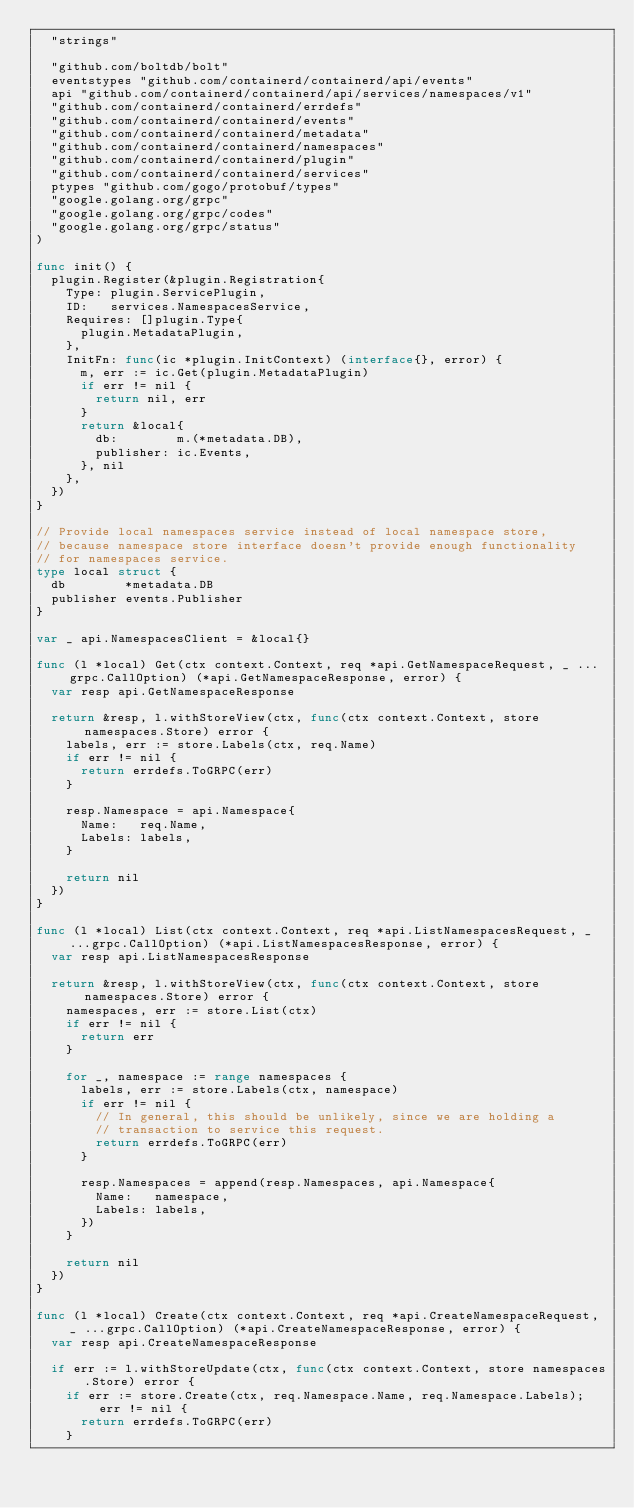<code> <loc_0><loc_0><loc_500><loc_500><_Go_>	"strings"

	"github.com/boltdb/bolt"
	eventstypes "github.com/containerd/containerd/api/events"
	api "github.com/containerd/containerd/api/services/namespaces/v1"
	"github.com/containerd/containerd/errdefs"
	"github.com/containerd/containerd/events"
	"github.com/containerd/containerd/metadata"
	"github.com/containerd/containerd/namespaces"
	"github.com/containerd/containerd/plugin"
	"github.com/containerd/containerd/services"
	ptypes "github.com/gogo/protobuf/types"
	"google.golang.org/grpc"
	"google.golang.org/grpc/codes"
	"google.golang.org/grpc/status"
)

func init() {
	plugin.Register(&plugin.Registration{
		Type: plugin.ServicePlugin,
		ID:   services.NamespacesService,
		Requires: []plugin.Type{
			plugin.MetadataPlugin,
		},
		InitFn: func(ic *plugin.InitContext) (interface{}, error) {
			m, err := ic.Get(plugin.MetadataPlugin)
			if err != nil {
				return nil, err
			}
			return &local{
				db:        m.(*metadata.DB),
				publisher: ic.Events,
			}, nil
		},
	})
}

// Provide local namespaces service instead of local namespace store,
// because namespace store interface doesn't provide enough functionality
// for namespaces service.
type local struct {
	db        *metadata.DB
	publisher events.Publisher
}

var _ api.NamespacesClient = &local{}

func (l *local) Get(ctx context.Context, req *api.GetNamespaceRequest, _ ...grpc.CallOption) (*api.GetNamespaceResponse, error) {
	var resp api.GetNamespaceResponse

	return &resp, l.withStoreView(ctx, func(ctx context.Context, store namespaces.Store) error {
		labels, err := store.Labels(ctx, req.Name)
		if err != nil {
			return errdefs.ToGRPC(err)
		}

		resp.Namespace = api.Namespace{
			Name:   req.Name,
			Labels: labels,
		}

		return nil
	})
}

func (l *local) List(ctx context.Context, req *api.ListNamespacesRequest, _ ...grpc.CallOption) (*api.ListNamespacesResponse, error) {
	var resp api.ListNamespacesResponse

	return &resp, l.withStoreView(ctx, func(ctx context.Context, store namespaces.Store) error {
		namespaces, err := store.List(ctx)
		if err != nil {
			return err
		}

		for _, namespace := range namespaces {
			labels, err := store.Labels(ctx, namespace)
			if err != nil {
				// In general, this should be unlikely, since we are holding a
				// transaction to service this request.
				return errdefs.ToGRPC(err)
			}

			resp.Namespaces = append(resp.Namespaces, api.Namespace{
				Name:   namespace,
				Labels: labels,
			})
		}

		return nil
	})
}

func (l *local) Create(ctx context.Context, req *api.CreateNamespaceRequest, _ ...grpc.CallOption) (*api.CreateNamespaceResponse, error) {
	var resp api.CreateNamespaceResponse

	if err := l.withStoreUpdate(ctx, func(ctx context.Context, store namespaces.Store) error {
		if err := store.Create(ctx, req.Namespace.Name, req.Namespace.Labels); err != nil {
			return errdefs.ToGRPC(err)
		}
</code> 